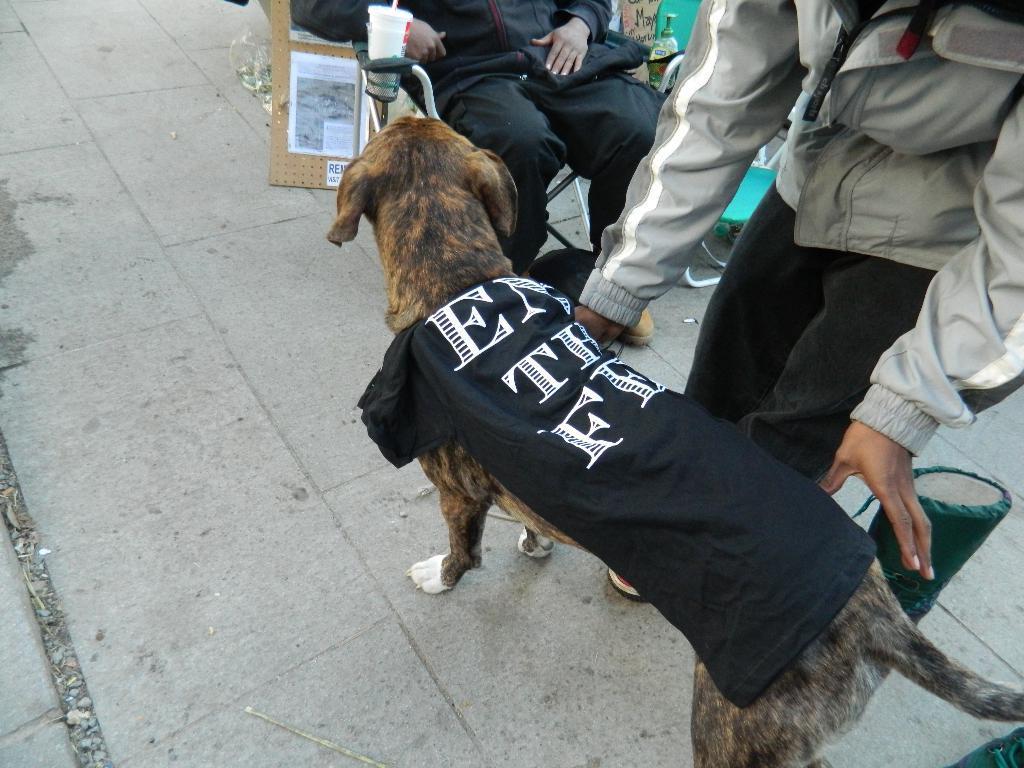Describe this image in one or two sentences. The picture is taken on the road where at the right corner of the picture one person standing and in front of him there is a dog wearing a black shirt in front of dog there is one person sitting on the chair in the black dress, behind him there is one cart board beside the person there is one small bottle and chair is present. 